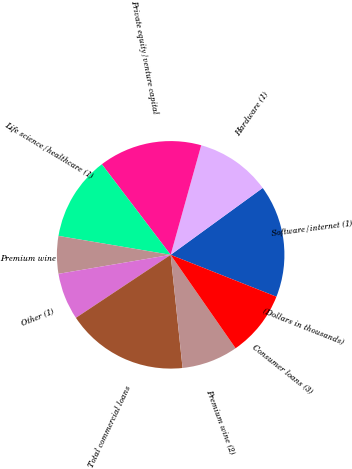Convert chart to OTSL. <chart><loc_0><loc_0><loc_500><loc_500><pie_chart><fcel>(Dollars in thousands)<fcel>Software/internet (1)<fcel>Hardware (1)<fcel>Private equity/venture capital<fcel>Life science/healthcare (1)<fcel>Premium wine<fcel>Other (1)<fcel>Total commercial loans<fcel>Premium wine (2)<fcel>Consumer loans (3)<nl><fcel>0.0%<fcel>16.0%<fcel>10.67%<fcel>14.67%<fcel>12.0%<fcel>5.33%<fcel>6.67%<fcel>17.33%<fcel>8.0%<fcel>9.33%<nl></chart> 